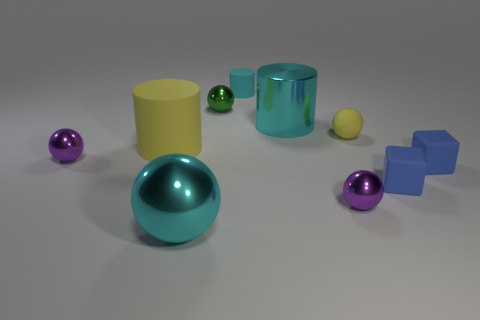Is the number of green metallic spheres that are in front of the small yellow rubber ball the same as the number of large green blocks?
Give a very brief answer. Yes. Are there any purple metallic balls of the same size as the yellow rubber cylinder?
Keep it short and to the point. No. There is a cyan matte cylinder; is its size the same as the cylinder to the left of the green metallic thing?
Provide a succinct answer. No. Is the number of tiny green spheres that are behind the large shiny ball the same as the number of yellow cylinders that are right of the big yellow rubber object?
Keep it short and to the point. No. There is a small thing that is the same color as the big rubber cylinder; what shape is it?
Your answer should be compact. Sphere. There is a thing to the left of the big matte cylinder; what material is it?
Ensure brevity in your answer.  Metal. Does the yellow matte ball have the same size as the yellow cylinder?
Keep it short and to the point. No. Are there more green metallic balls to the right of the large cyan cylinder than shiny spheres?
Make the answer very short. No. There is a cyan object that is made of the same material as the large yellow thing; what is its size?
Keep it short and to the point. Small. Are there any small cylinders in front of the big yellow rubber cylinder?
Offer a very short reply. No. 